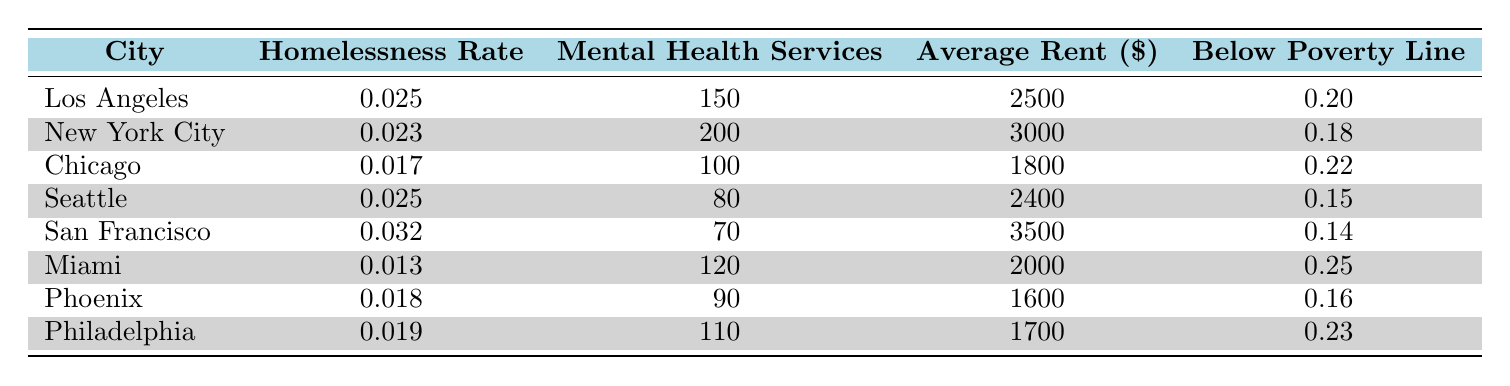What is the homelessness rate in San Francisco? According to the table, the homelessness rate for San Francisco is listed as 0.032.
Answer: 0.032 Which city has the highest number of mental health services available? By looking at the "Mental Health Services" column, New York City has the highest availability with 200 services.
Answer: New York City What is the average rent for cities with a homelessness rate above 0.02? First, identify the cities with a homelessness rate above 0.02: Los Angeles, Seattle, San Francisco. Their rents are 2500, 2400, and 3500 respectively. The average is calculated as (2500 + 2400 + 3500) / 3 = 2466.67.
Answer: 2466.67 Is the percentage of people below the poverty line in Miami higher than that in Seattle? Miami has a poverty line percentage of 0.25 while Seattle's is 0.15. Since 0.25 is greater than 0.15, the statement is true.
Answer: Yes Which city has the lowest availability of mental health services along with the highest homelessness rate? A review of the table reveals that San Francisco has the lowest availability of mental health services at 70 and the highest homelessness rate at 0.032 among the identified cities.
Answer: San Francisco 